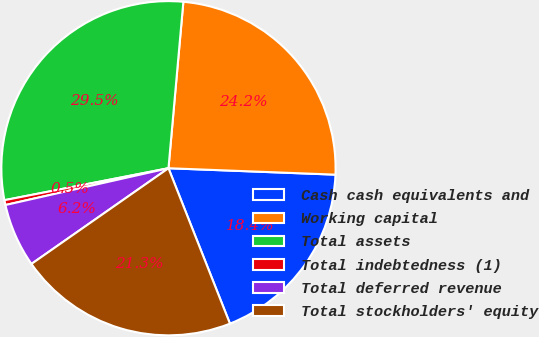<chart> <loc_0><loc_0><loc_500><loc_500><pie_chart><fcel>Cash cash equivalents and<fcel>Working capital<fcel>Total assets<fcel>Total indebtedness (1)<fcel>Total deferred revenue<fcel>Total stockholders' equity<nl><fcel>18.39%<fcel>24.19%<fcel>29.48%<fcel>0.47%<fcel>6.17%<fcel>21.29%<nl></chart> 